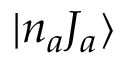<formula> <loc_0><loc_0><loc_500><loc_500>{ | n _ { a } J _ { a } \rangle }</formula> 